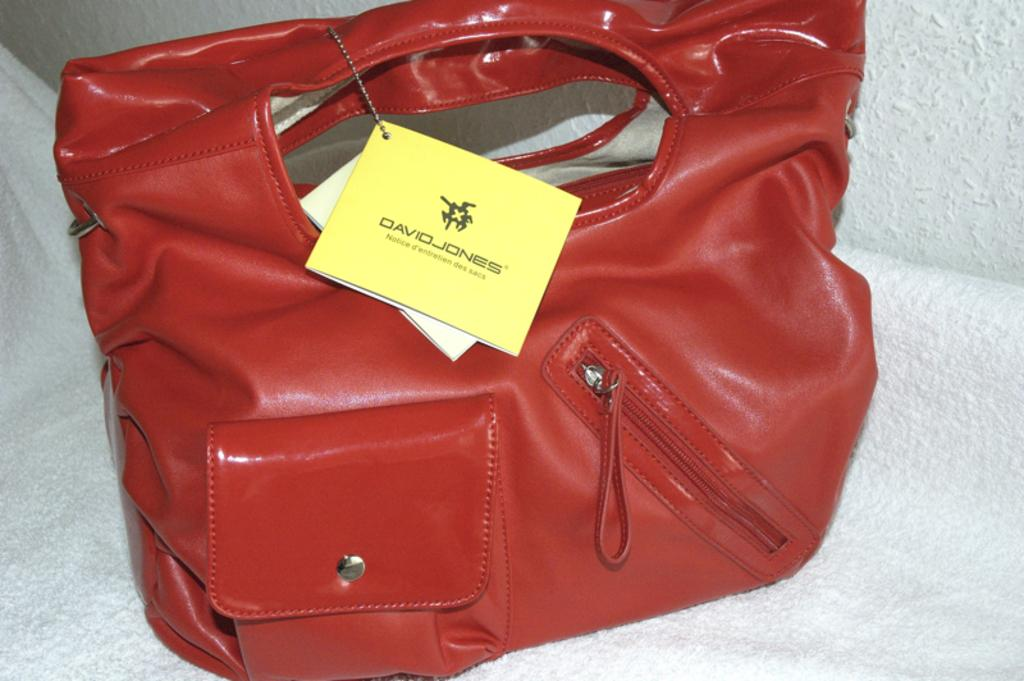What type of handbag is featured in the image? There is a beautiful red handbag in the image. Can you describe the color of the handbag? The handbag is red. Is there a bear kissing the secretary in the image? There is no bear or secretary present in the image; it only features a beautiful red handbag. 